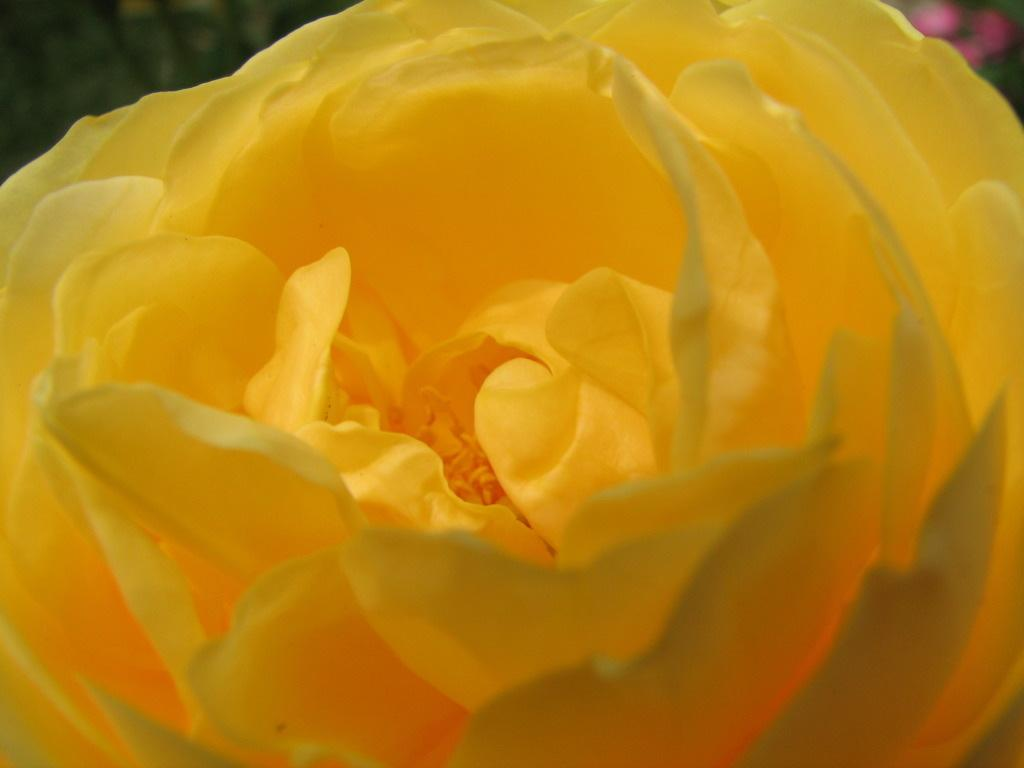What is the main subject of the picture? The main subject of the picture is a flower. Can you describe the color of the flower? The flower is yellow in color. What type of appliance is being used to celebrate the birthday in the image? There is no appliance or birthday celebration present in the image; it only features a yellow flower. 